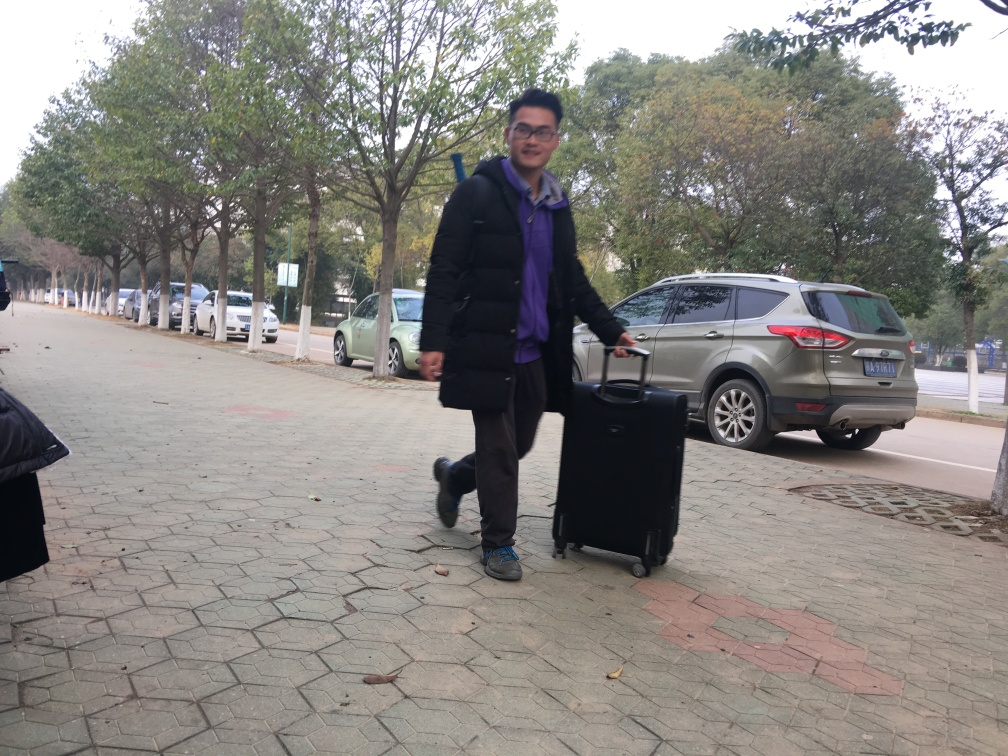What caused the motion blur in this photo? The motion blur in this photo is caused by the relatively slow shutter speed of the camera during the capture of a moving subject, which in this case appears to be a person walking and pulling a suitcase. 